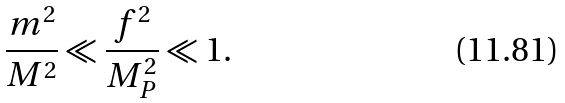<formula> <loc_0><loc_0><loc_500><loc_500>\frac { m ^ { 2 } } { M ^ { 2 } } \ll \frac { f ^ { 2 } } { M _ { P } ^ { 2 } } \ll 1 .</formula> 